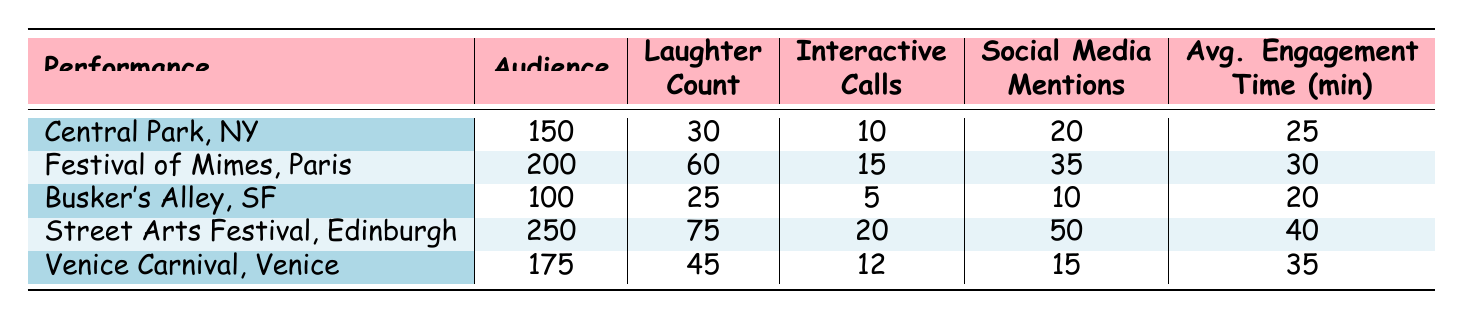What was the average audience size across all performances? To find the average audience size, add the audience sizes of all performances: 150 + 200 + 100 + 250 + 175 = 875. Then, divide the total by the number of performances, which is 5: 875 / 5 = 175.
Answer: 175 Which performance had the highest laughter count? By inspecting the laughter count column, the performances are as follows: Central Park (30), Festival of Mimes (60), Busker's Alley (25), Street Arts Festival (75), and Venice Carnival (45). The highest laughter count is 75 from the Street Arts Festival.
Answer: Street Arts Festival Did the Festival of Mimes have more interactive calls than the Venice Carnival? Comparing the interactive calls: Festival of Mimes had 15 calls while Venice Carnival had 12 calls. Since 15 is greater than 12, the Festival of Mimes indeed had more interactive calls.
Answer: Yes What is the total number of social media mentions from all performances? To find the total social media mentions, add the values: 20 (Central Park) + 35 (Festival of Mimes) + 10 (Busker's Alley) + 50 (Street Arts Festival) + 15 (Venice Carnival) = 130.
Answer: 130 How does the average engagement time of the Street Arts Festival compare to the average of the performances? First, calculate the average engagement time for all performances: (25 + 30 + 20 + 40 + 35) / 5 = 28. Then compare it to the Street Arts Festival's time, which is 40. Since 40 is greater than 28, the Street Arts Festival had higher engagement.
Answer: Higher What is the median audience size among the performances listed? To find the median, first list the audience sizes in ascending order: 100, 150, 175, 200, 250. Since there are 5 values, the median is the middle one, which is the third value: 175.
Answer: 175 Did any performance have an average engagement time of more than 35 minutes? Checking the average engagement time, we see: Central Park (25), Festival of Mimes (30), Busker's Alley (20), Street Arts Festival (40), Venice Carnival (35). Only the Street Arts Festival exceeds 35 minutes.
Answer: Yes What was the total laughter count from performances that had an audience size greater than 150? First, identify performances with audience sizes greater than 150: Festival of Mimes (60) and Street Arts Festival (75). Adding these laughter counts gives us 60 + 75 = 135.
Answer: 135 